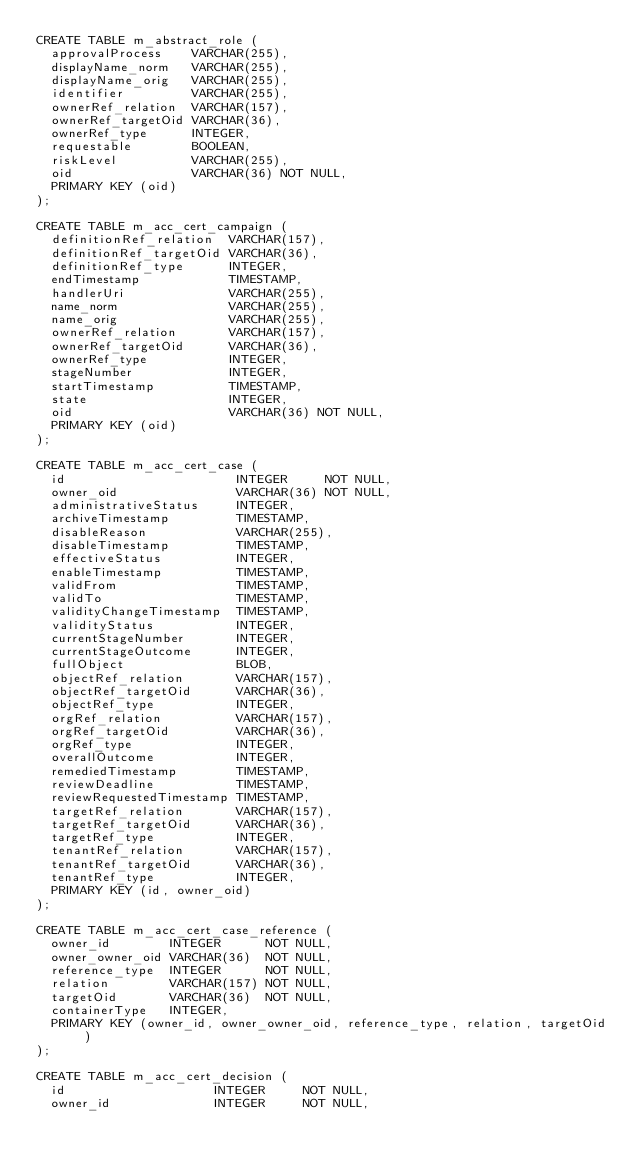Convert code to text. <code><loc_0><loc_0><loc_500><loc_500><_SQL_>CREATE TABLE m_abstract_role (
  approvalProcess    VARCHAR(255),
  displayName_norm   VARCHAR(255),
  displayName_orig   VARCHAR(255),
  identifier         VARCHAR(255),
  ownerRef_relation  VARCHAR(157),
  ownerRef_targetOid VARCHAR(36),
  ownerRef_type      INTEGER,
  requestable        BOOLEAN,
  riskLevel          VARCHAR(255),
  oid                VARCHAR(36) NOT NULL,
  PRIMARY KEY (oid)
);

CREATE TABLE m_acc_cert_campaign (
  definitionRef_relation  VARCHAR(157),
  definitionRef_targetOid VARCHAR(36),
  definitionRef_type      INTEGER,
  endTimestamp            TIMESTAMP,
  handlerUri              VARCHAR(255),
  name_norm               VARCHAR(255),
  name_orig               VARCHAR(255),
  ownerRef_relation       VARCHAR(157),
  ownerRef_targetOid      VARCHAR(36),
  ownerRef_type           INTEGER,
  stageNumber             INTEGER,
  startTimestamp          TIMESTAMP,
  state                   INTEGER,
  oid                     VARCHAR(36) NOT NULL,
  PRIMARY KEY (oid)
);

CREATE TABLE m_acc_cert_case (
  id                       INTEGER     NOT NULL,
  owner_oid                VARCHAR(36) NOT NULL,
  administrativeStatus     INTEGER,
  archiveTimestamp         TIMESTAMP,
  disableReason            VARCHAR(255),
  disableTimestamp         TIMESTAMP,
  effectiveStatus          INTEGER,
  enableTimestamp          TIMESTAMP,
  validFrom                TIMESTAMP,
  validTo                  TIMESTAMP,
  validityChangeTimestamp  TIMESTAMP,
  validityStatus           INTEGER,
  currentStageNumber       INTEGER,
  currentStageOutcome      INTEGER,
  fullObject               BLOB,
  objectRef_relation       VARCHAR(157),
  objectRef_targetOid      VARCHAR(36),
  objectRef_type           INTEGER,
  orgRef_relation          VARCHAR(157),
  orgRef_targetOid         VARCHAR(36),
  orgRef_type              INTEGER,
  overallOutcome           INTEGER,
  remediedTimestamp        TIMESTAMP,
  reviewDeadline           TIMESTAMP,
  reviewRequestedTimestamp TIMESTAMP,
  targetRef_relation       VARCHAR(157),
  targetRef_targetOid      VARCHAR(36),
  targetRef_type           INTEGER,
  tenantRef_relation       VARCHAR(157),
  tenantRef_targetOid      VARCHAR(36),
  tenantRef_type           INTEGER,
  PRIMARY KEY (id, owner_oid)
);

CREATE TABLE m_acc_cert_case_reference (
  owner_id        INTEGER      NOT NULL,
  owner_owner_oid VARCHAR(36)  NOT NULL,
  reference_type  INTEGER      NOT NULL,
  relation        VARCHAR(157) NOT NULL,
  targetOid       VARCHAR(36)  NOT NULL,
  containerType   INTEGER,
  PRIMARY KEY (owner_id, owner_owner_oid, reference_type, relation, targetOid)
);

CREATE TABLE m_acc_cert_decision (
  id                    INTEGER     NOT NULL,
  owner_id              INTEGER     NOT NULL,</code> 